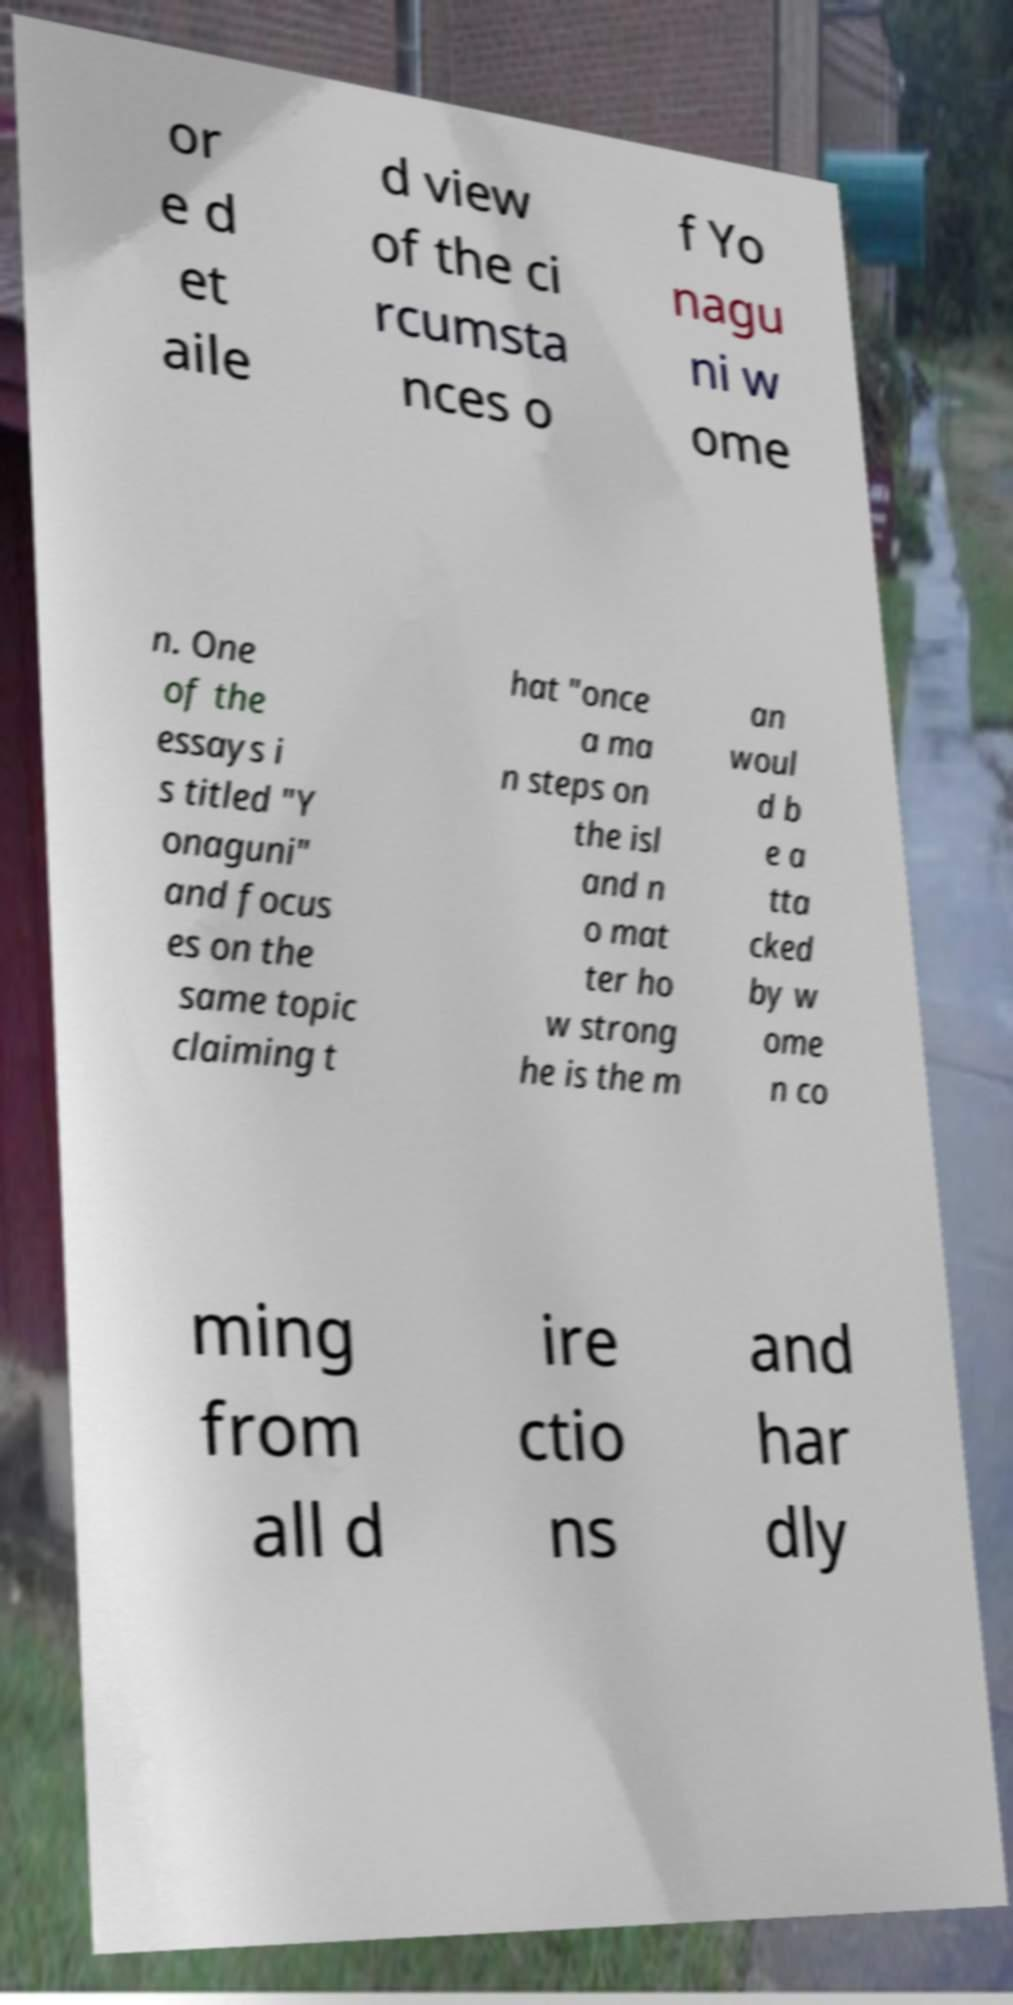Can you read and provide the text displayed in the image?This photo seems to have some interesting text. Can you extract and type it out for me? or e d et aile d view of the ci rcumsta nces o f Yo nagu ni w ome n. One of the essays i s titled "Y onaguni" and focus es on the same topic claiming t hat "once a ma n steps on the isl and n o mat ter ho w strong he is the m an woul d b e a tta cked by w ome n co ming from all d ire ctio ns and har dly 